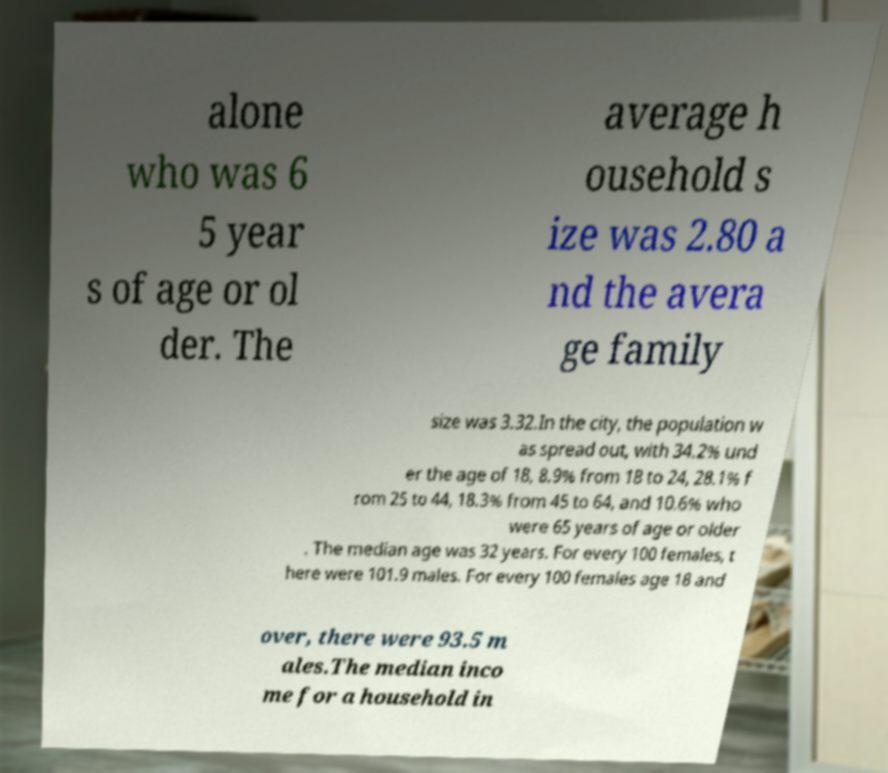Could you extract and type out the text from this image? alone who was 6 5 year s of age or ol der. The average h ousehold s ize was 2.80 a nd the avera ge family size was 3.32.In the city, the population w as spread out, with 34.2% und er the age of 18, 8.9% from 18 to 24, 28.1% f rom 25 to 44, 18.3% from 45 to 64, and 10.6% who were 65 years of age or older . The median age was 32 years. For every 100 females, t here were 101.9 males. For every 100 females age 18 and over, there were 93.5 m ales.The median inco me for a household in 